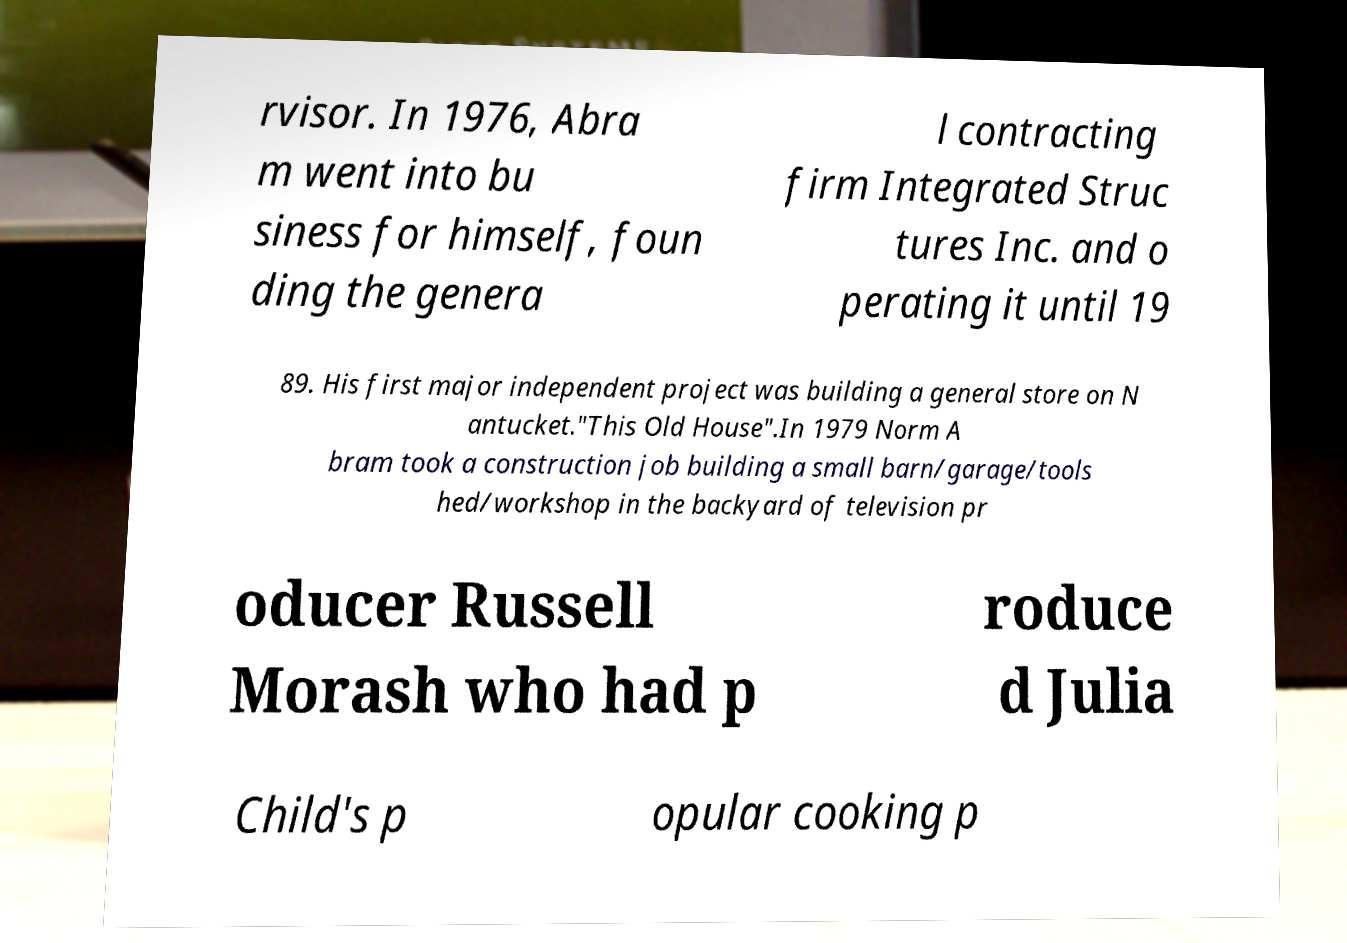Please identify and transcribe the text found in this image. rvisor. In 1976, Abra m went into bu siness for himself, foun ding the genera l contracting firm Integrated Struc tures Inc. and o perating it until 19 89. His first major independent project was building a general store on N antucket."This Old House".In 1979 Norm A bram took a construction job building a small barn/garage/tools hed/workshop in the backyard of television pr oducer Russell Morash who had p roduce d Julia Child's p opular cooking p 